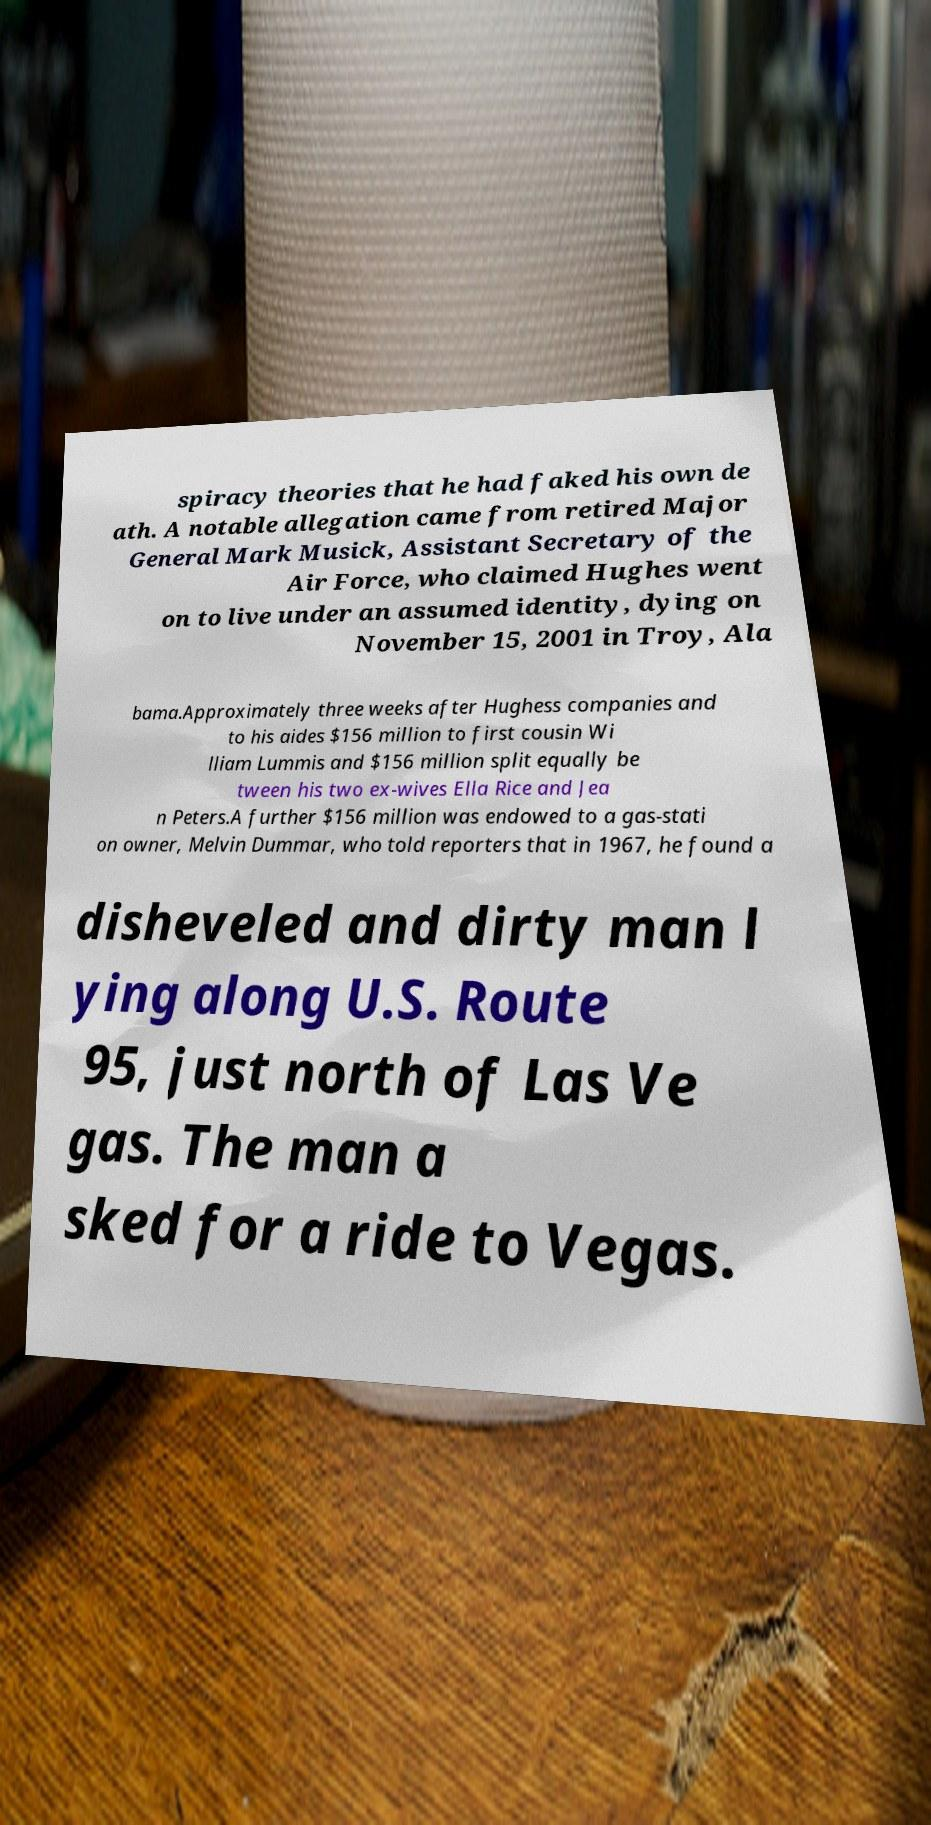Could you assist in decoding the text presented in this image and type it out clearly? spiracy theories that he had faked his own de ath. A notable allegation came from retired Major General Mark Musick, Assistant Secretary of the Air Force, who claimed Hughes went on to live under an assumed identity, dying on November 15, 2001 in Troy, Ala bama.Approximately three weeks after Hughess companies and to his aides $156 million to first cousin Wi lliam Lummis and $156 million split equally be tween his two ex-wives Ella Rice and Jea n Peters.A further $156 million was endowed to a gas-stati on owner, Melvin Dummar, who told reporters that in 1967, he found a disheveled and dirty man l ying along U.S. Route 95, just north of Las Ve gas. The man a sked for a ride to Vegas. 